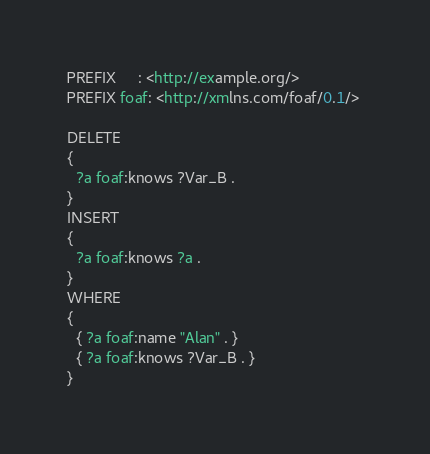<code> <loc_0><loc_0><loc_500><loc_500><_Ruby_>PREFIX     : <http://example.org/> 
PREFIX foaf: <http://xmlns.com/foaf/0.1/> 

DELETE 
{
  ?a foaf:knows ?Var_B .
}
INSERT
{
  ?a foaf:knows ?a .
}
WHERE
{
  { ?a foaf:name "Alan" . }
  { ?a foaf:knows ?Var_B . }
}
</code> 